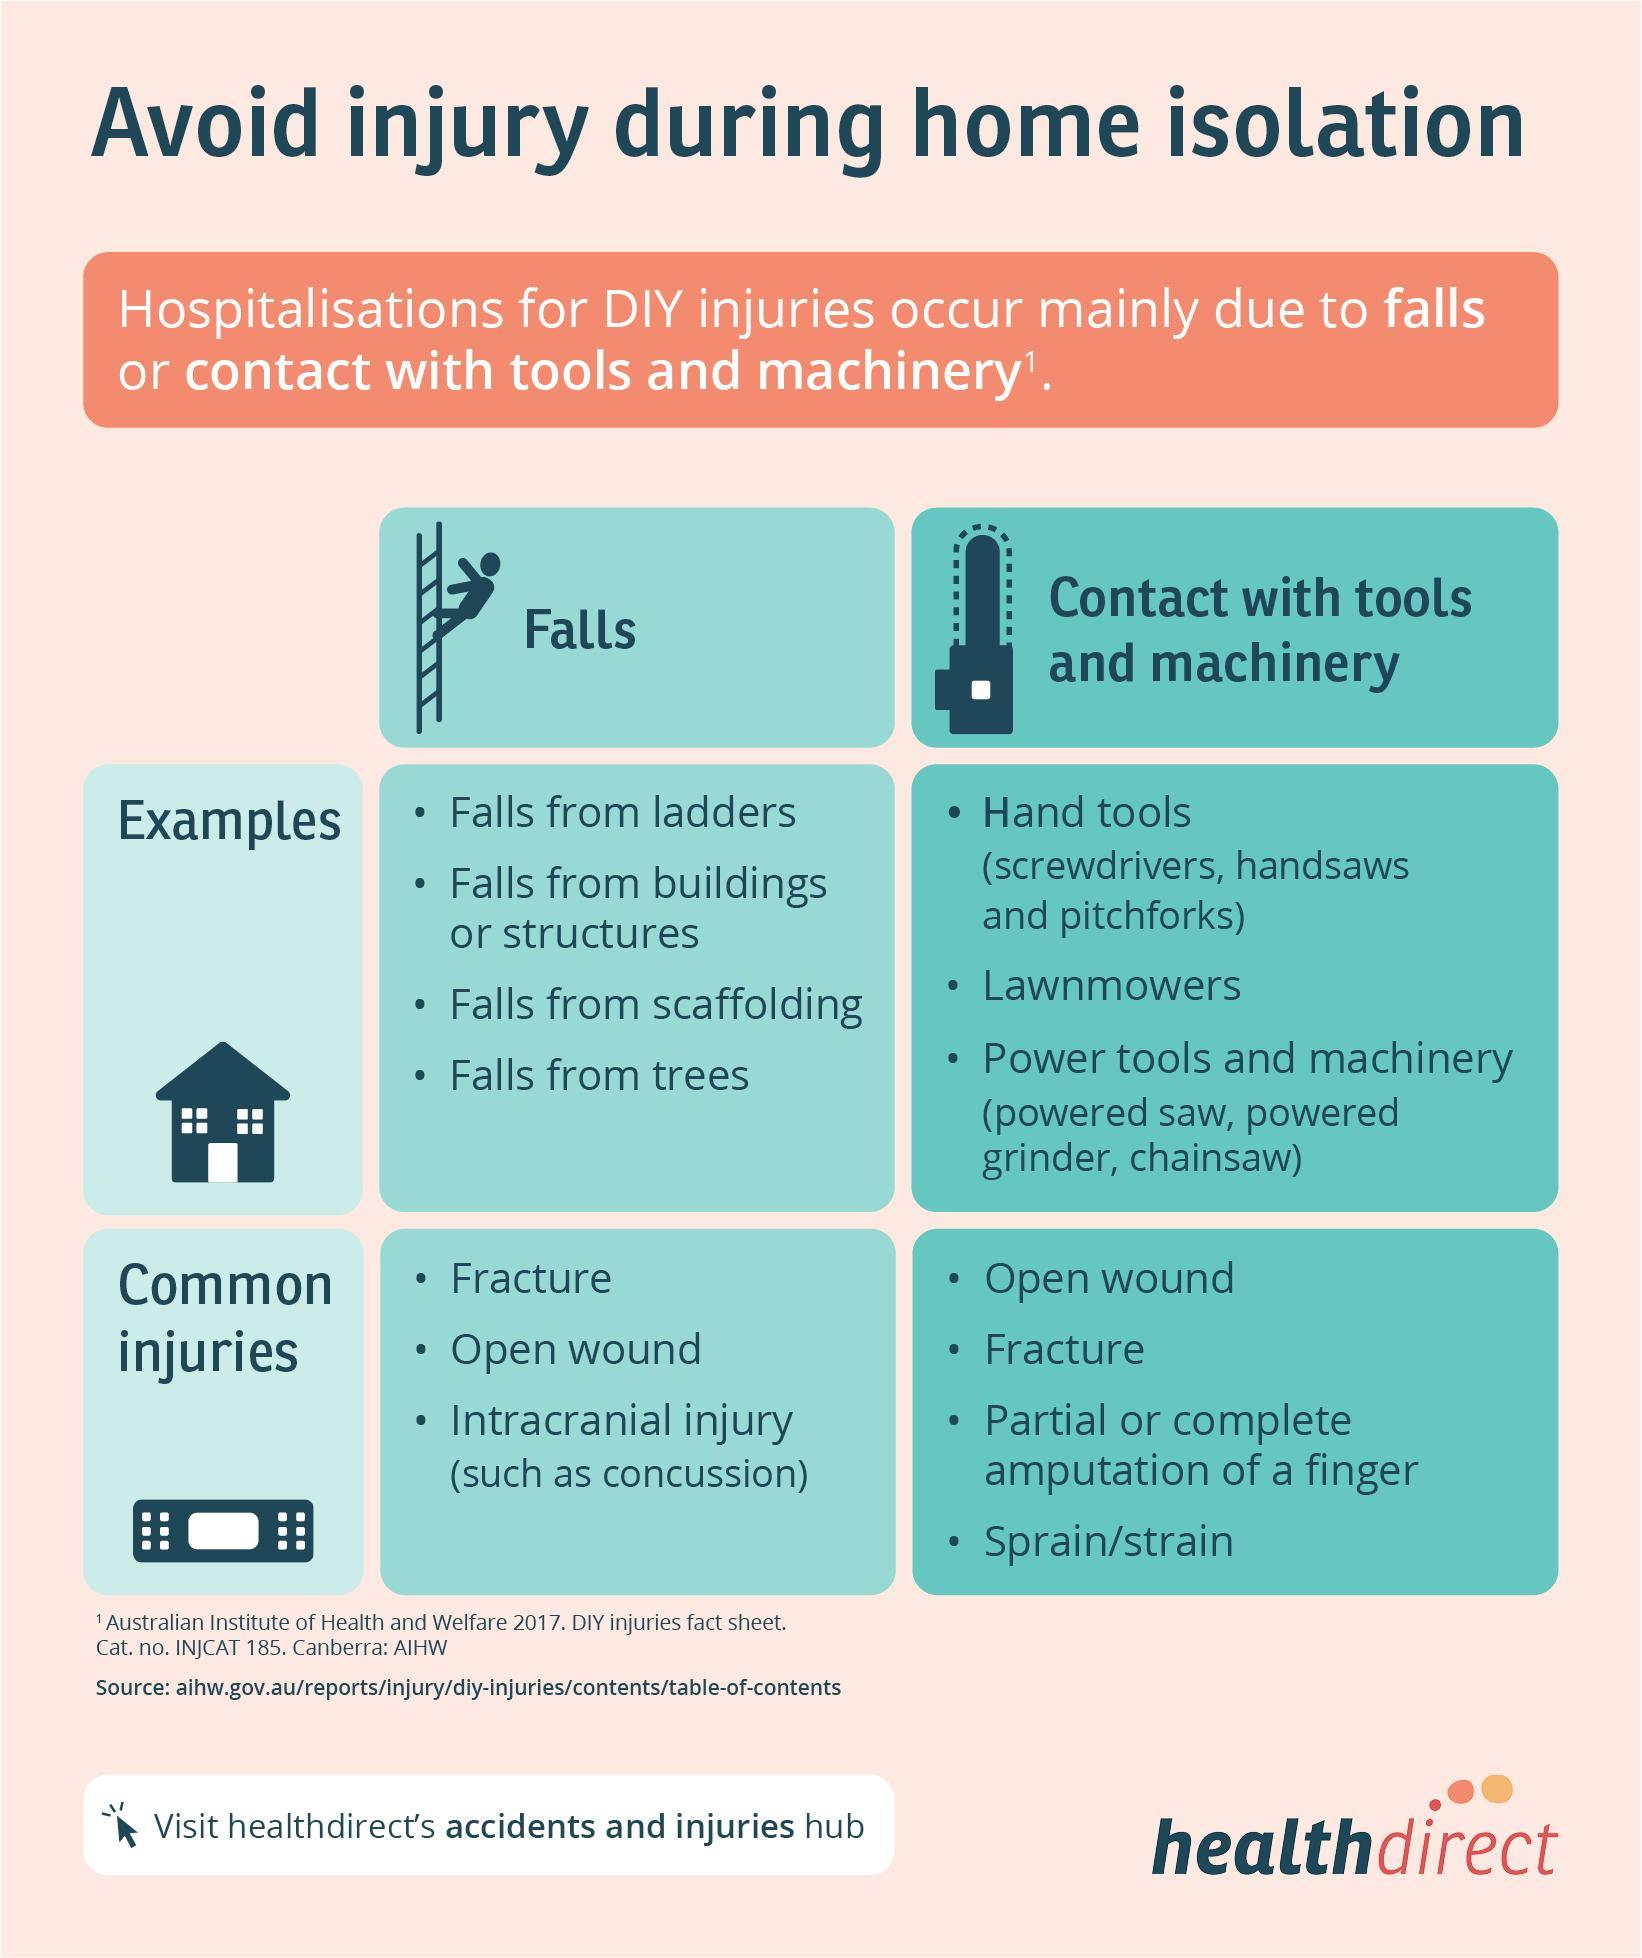How many types of tools and machinery are listed?
Answer the question with a short phrase. 3 How many injuries due to contact with tools and machinery are listed? 4 How many common types of Injuries due to falls are listed? 3 How many different types of falls are listed in the info graphic? 4 